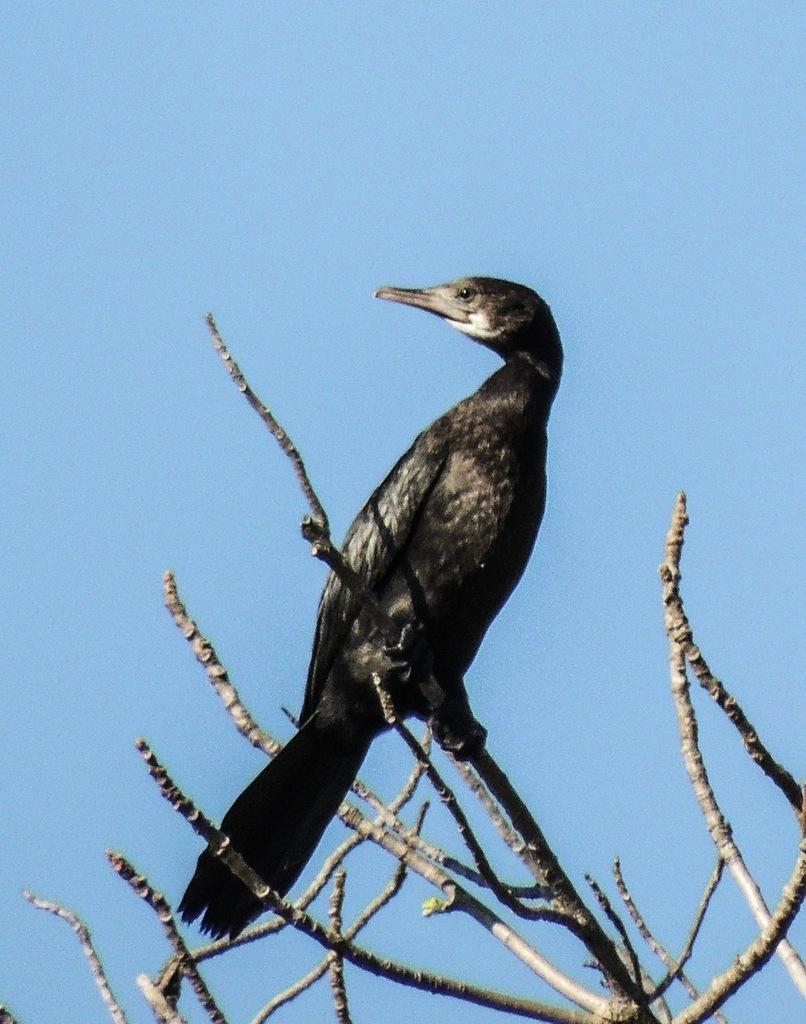How would you summarize this image in a sentence or two? In this image there is one bird on a tree, and in the background there is sky. 